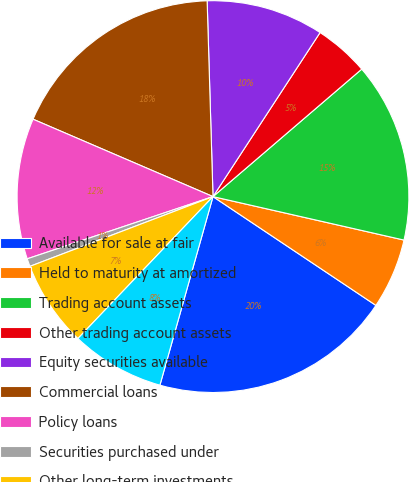<chart> <loc_0><loc_0><loc_500><loc_500><pie_chart><fcel>Available for sale at fair<fcel>Held to maturity at amortized<fcel>Trading account assets<fcel>Other trading account assets<fcel>Equity securities available<fcel>Commercial loans<fcel>Policy loans<fcel>Securities purchased under<fcel>Other long-term investments<fcel>Short-term investments<nl><fcel>20.0%<fcel>5.81%<fcel>14.84%<fcel>4.52%<fcel>9.68%<fcel>18.06%<fcel>11.61%<fcel>0.65%<fcel>7.1%<fcel>7.74%<nl></chart> 